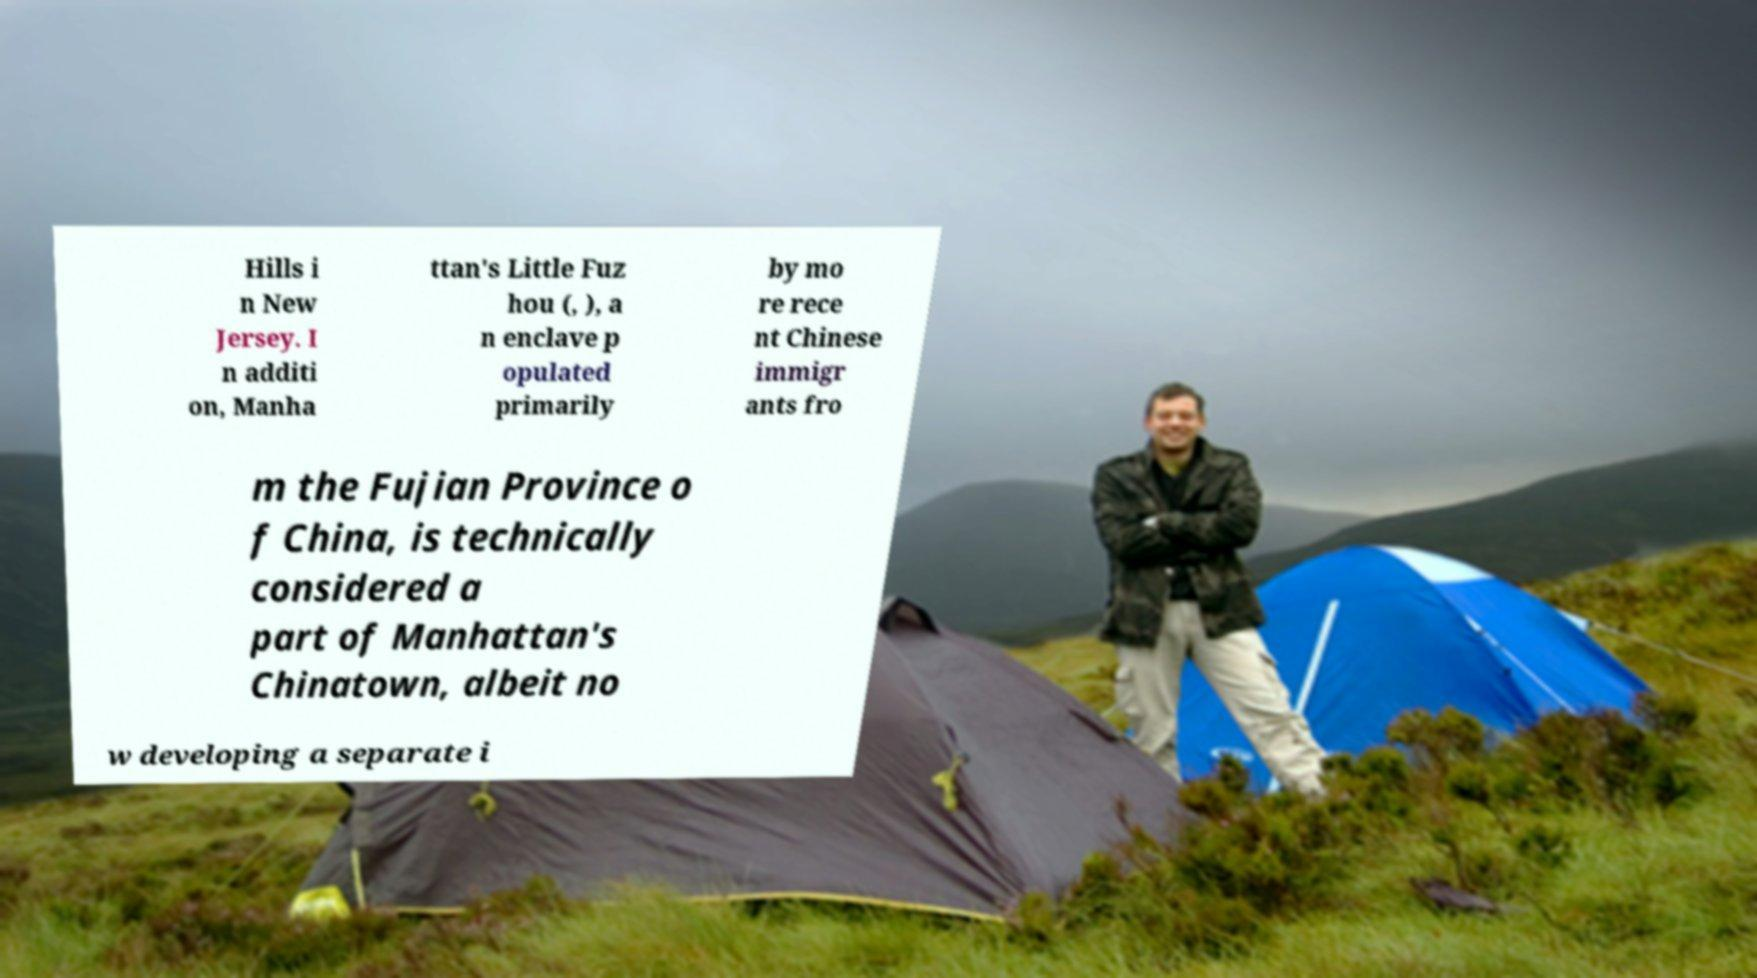Can you accurately transcribe the text from the provided image for me? Hills i n New Jersey. I n additi on, Manha ttan's Little Fuz hou (, ), a n enclave p opulated primarily by mo re rece nt Chinese immigr ants fro m the Fujian Province o f China, is technically considered a part of Manhattan's Chinatown, albeit no w developing a separate i 